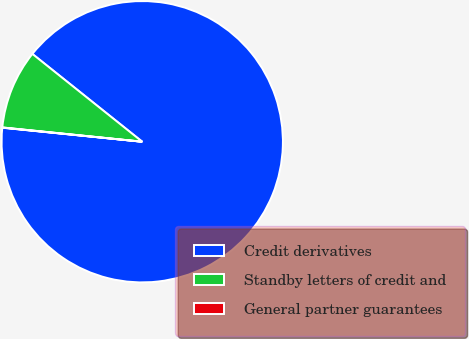<chart> <loc_0><loc_0><loc_500><loc_500><pie_chart><fcel>Credit derivatives<fcel>Standby letters of credit and<fcel>General partner guarantees<nl><fcel>90.85%<fcel>9.11%<fcel>0.03%<nl></chart> 